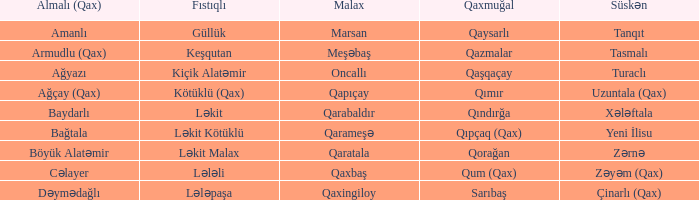I'm looking to parse the entire table for insights. Could you assist me with that? {'header': ['Almalı (Qax)', 'Fıstıqlı', 'Malax', 'Qaxmuğal', 'Süskən'], 'rows': [['Amanlı', 'Güllük', 'Marsan', 'Qaysarlı', 'Tanqıt'], ['Armudlu (Qax)', 'Keşqutan', 'Meşəbaş', 'Qazmalar', 'Tasmalı'], ['Ağyazı', 'Kiçik Alatəmir', 'Oncallı', 'Qaşqaçay', 'Turaclı'], ['Ağçay (Qax)', 'Kötüklü (Qax)', 'Qapıçay', 'Qımır', 'Uzuntala (Qax)'], ['Baydarlı', 'Ləkit', 'Qarabaldır', 'Qındırğa', 'Xələftala'], ['Bağtala', 'Ləkit Kötüklü', 'Qarameşə', 'Qıpçaq (Qax)', 'Yeni İlisu'], ['Böyük Alatəmir', 'Ləkit Malax', 'Qaratala', 'Qorağan', 'Zərnə'], ['Cəlayer', 'Lələli', 'Qaxbaş', 'Qum (Qax)', 'Zəyəm (Qax)'], ['Dəymədağlı', 'Lələpaşa', 'Qaxingiloy', 'Sarıbaş', 'Çinarlı (Qax)']]} What is the qaxmuğal village with a fistiqli village examination? Qazmalar. 